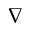<formula> <loc_0><loc_0><loc_500><loc_500>\nabla</formula> 